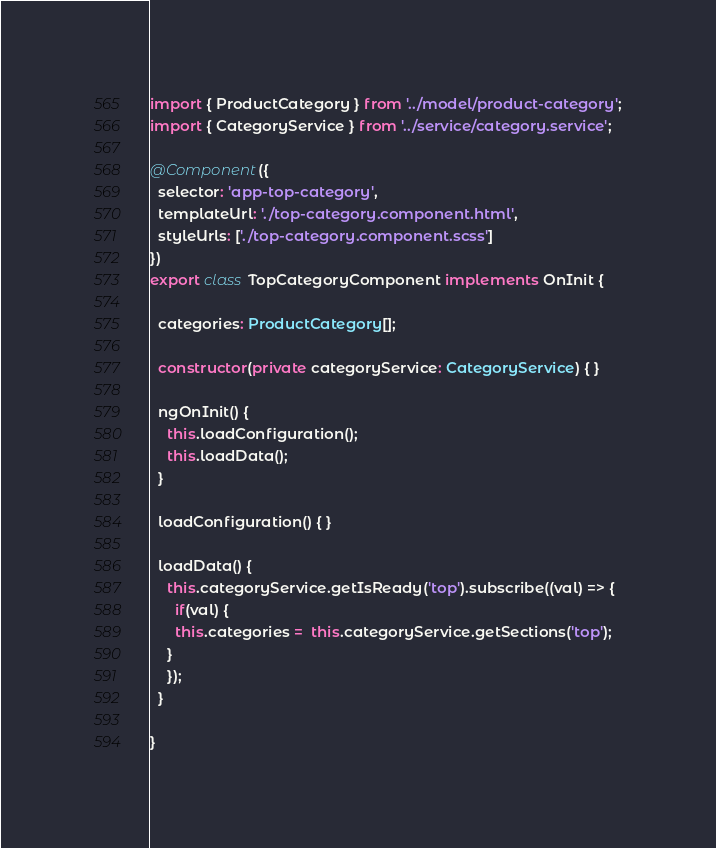<code> <loc_0><loc_0><loc_500><loc_500><_TypeScript_>import { ProductCategory } from '../model/product-category';
import { CategoryService } from '../service/category.service';

@Component({
  selector: 'app-top-category',
  templateUrl: './top-category.component.html',
  styleUrls: ['./top-category.component.scss']
})
export class TopCategoryComponent implements OnInit {

  categories: ProductCategory[];

  constructor(private categoryService: CategoryService) { }

  ngOnInit() {
    this.loadConfiguration();
    this.loadData();
  }

  loadConfiguration() { }

  loadData() {
    this.categoryService.getIsReady('top').subscribe((val) => {
      if(val) {
      this.categories =  this.categoryService.getSections('top');
    }
    });
  }

}
</code> 